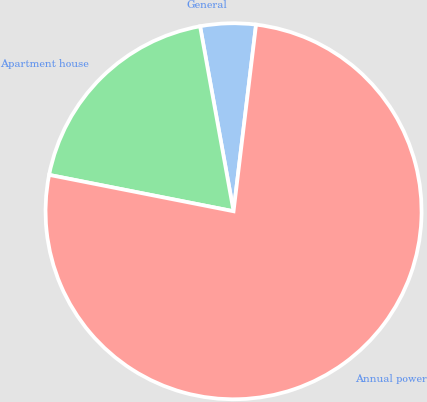<chart> <loc_0><loc_0><loc_500><loc_500><pie_chart><fcel>General<fcel>Apartment house<fcel>Annual power<nl><fcel>4.76%<fcel>19.05%<fcel>76.19%<nl></chart> 